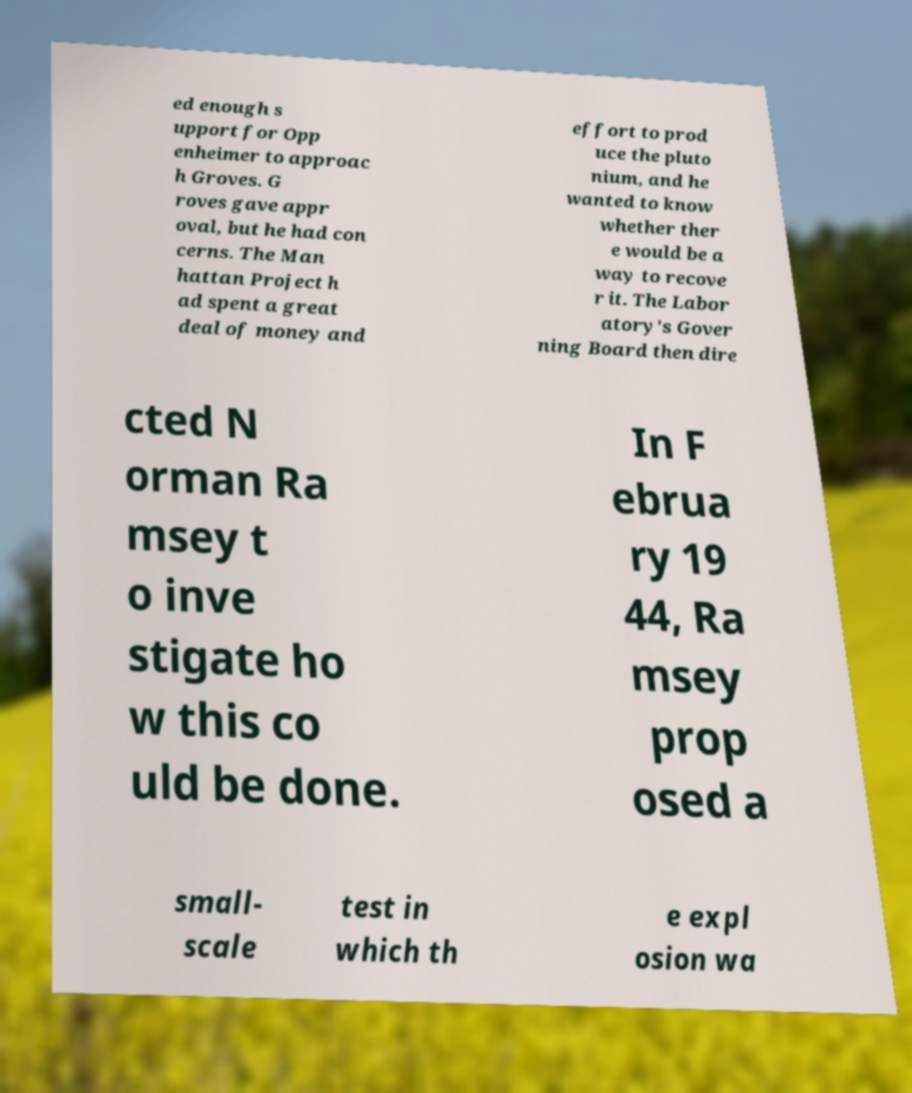Could you assist in decoding the text presented in this image and type it out clearly? ed enough s upport for Opp enheimer to approac h Groves. G roves gave appr oval, but he had con cerns. The Man hattan Project h ad spent a great deal of money and effort to prod uce the pluto nium, and he wanted to know whether ther e would be a way to recove r it. The Labor atory's Gover ning Board then dire cted N orman Ra msey t o inve stigate ho w this co uld be done. In F ebrua ry 19 44, Ra msey prop osed a small- scale test in which th e expl osion wa 